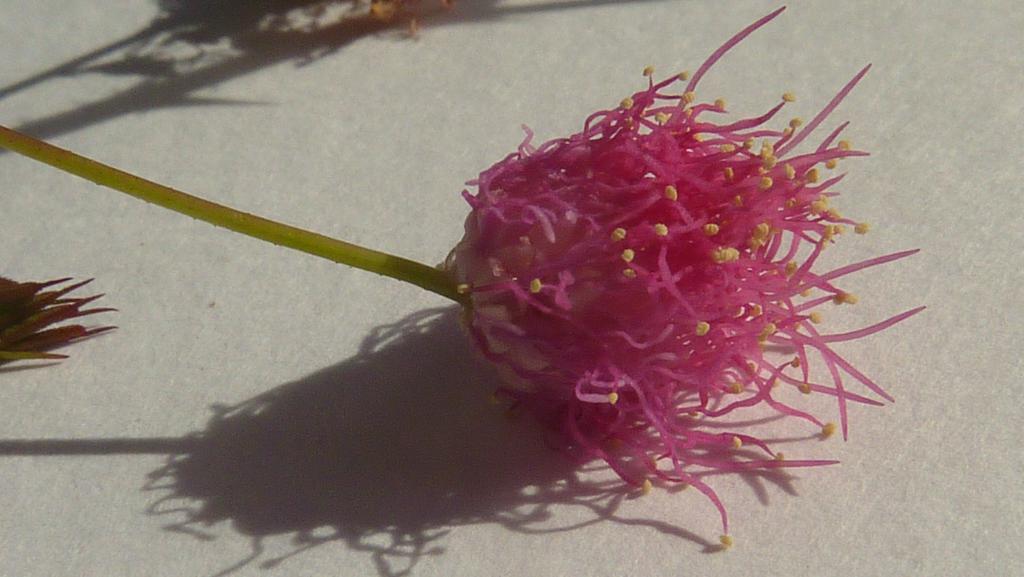How would you summarize this image in a sentence or two? In this image, I can see a flower with a stem. On the left side of the image, it looks like another flower. In the background, I can see the shadows on an object. 